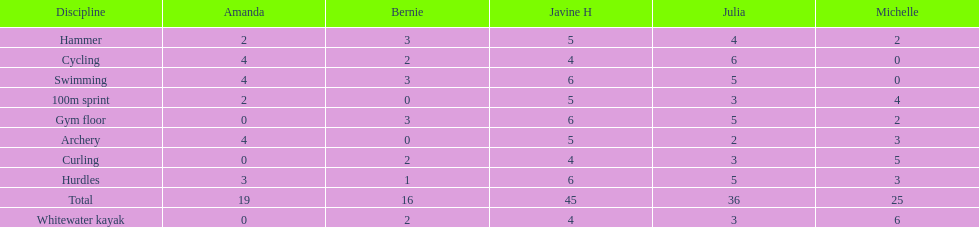Name a girl that had the same score in cycling and archery. Amanda. 